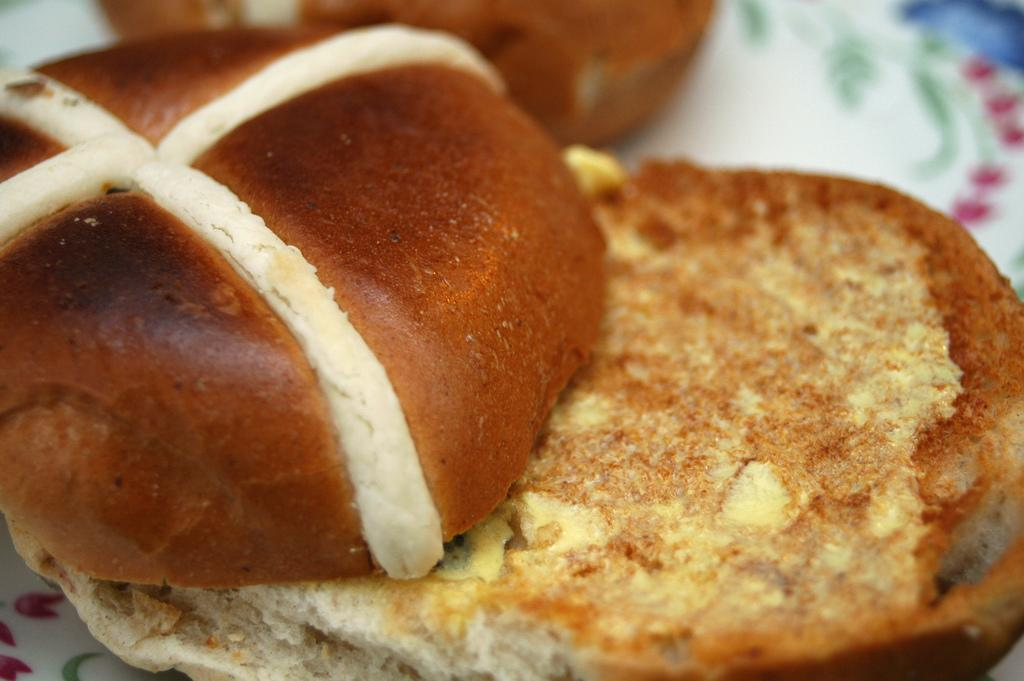What is on the plate that is visible in the image? There is food on a plate in the image. Can you describe the design on the plate? The plate has a white floral design. Where is the army located in the image? There is no army present in the image. What type of hand can be seen holding the plate in the image? There is no hand visible in the image; only the plate with food and its design are present. 